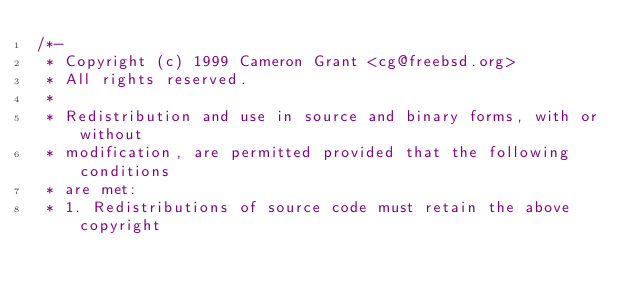<code> <loc_0><loc_0><loc_500><loc_500><_C_>/*-
 * Copyright (c) 1999 Cameron Grant <cg@freebsd.org>
 * All rights reserved.
 *
 * Redistribution and use in source and binary forms, with or without
 * modification, are permitted provided that the following conditions
 * are met:
 * 1. Redistributions of source code must retain the above copyright</code> 